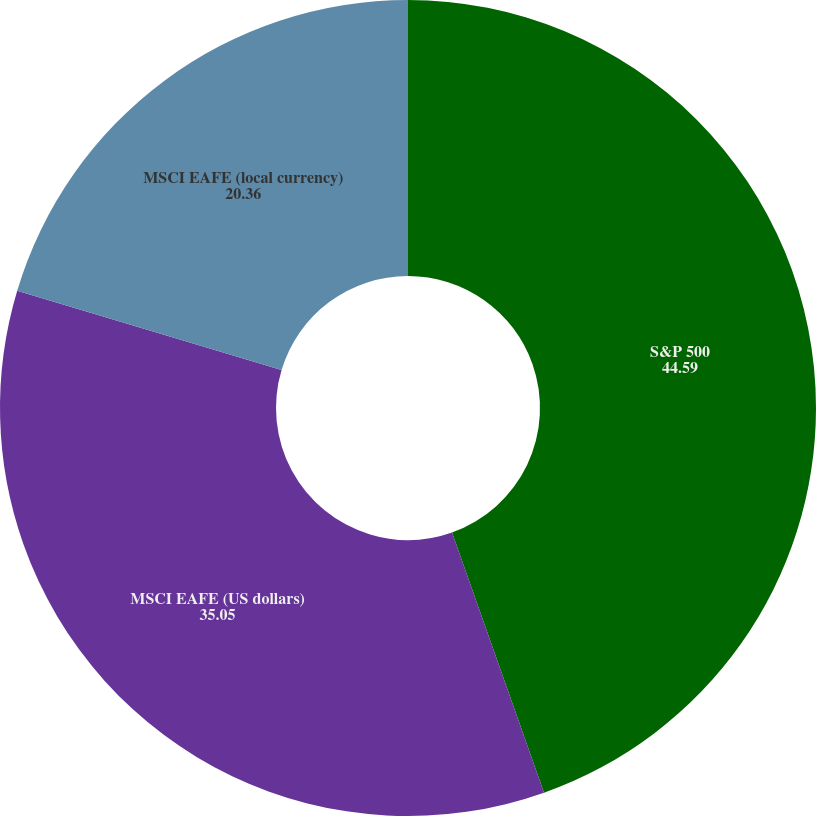<chart> <loc_0><loc_0><loc_500><loc_500><pie_chart><fcel>S&P 500<fcel>MSCI EAFE (US dollars)<fcel>MSCI EAFE (local currency)<nl><fcel>44.59%<fcel>35.05%<fcel>20.36%<nl></chart> 